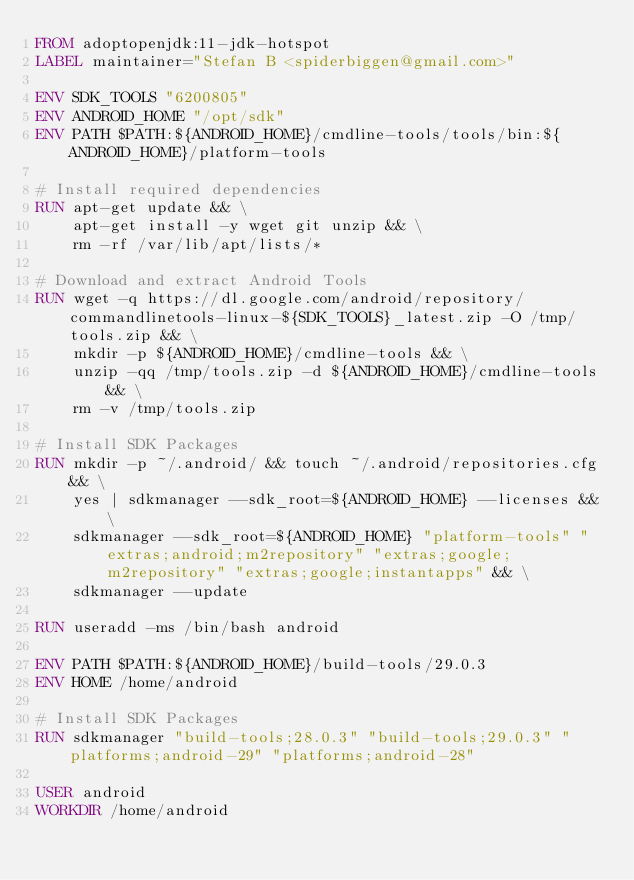<code> <loc_0><loc_0><loc_500><loc_500><_Dockerfile_>FROM adoptopenjdk:11-jdk-hotspot
LABEL maintainer="Stefan B <spiderbiggen@gmail.com>"

ENV SDK_TOOLS "6200805"
ENV ANDROID_HOME "/opt/sdk"
ENV PATH $PATH:${ANDROID_HOME}/cmdline-tools/tools/bin:${ANDROID_HOME}/platform-tools

# Install required dependencies
RUN apt-get update && \
    apt-get install -y wget git unzip && \
    rm -rf /var/lib/apt/lists/*

# Download and extract Android Tools
RUN wget -q https://dl.google.com/android/repository/commandlinetools-linux-${SDK_TOOLS}_latest.zip -O /tmp/tools.zip && \
    mkdir -p ${ANDROID_HOME}/cmdline-tools && \
    unzip -qq /tmp/tools.zip -d ${ANDROID_HOME}/cmdline-tools && \
    rm -v /tmp/tools.zip

# Install SDK Packages
RUN mkdir -p ~/.android/ && touch ~/.android/repositories.cfg && \
    yes | sdkmanager --sdk_root=${ANDROID_HOME} --licenses && \
    sdkmanager --sdk_root=${ANDROID_HOME} "platform-tools" "extras;android;m2repository" "extras;google;m2repository" "extras;google;instantapps" && \
    sdkmanager --update

RUN useradd -ms /bin/bash android

ENV PATH $PATH:${ANDROID_HOME}/build-tools/29.0.3
ENV HOME /home/android

# Install SDK Packages
RUN sdkmanager "build-tools;28.0.3" "build-tools;29.0.3" "platforms;android-29" "platforms;android-28"

USER android
WORKDIR /home/android</code> 